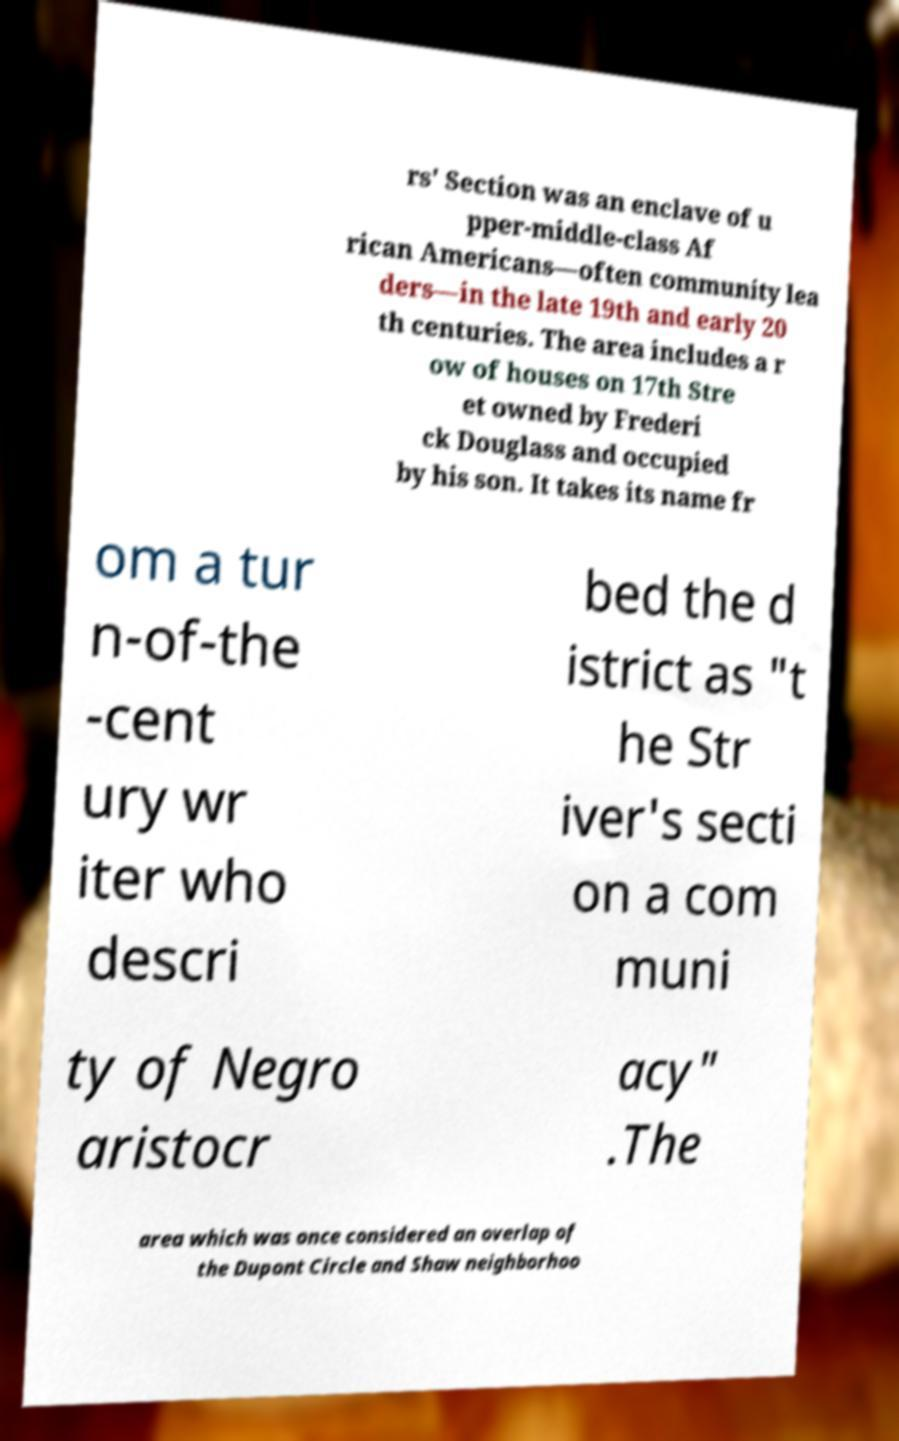There's text embedded in this image that I need extracted. Can you transcribe it verbatim? rs' Section was an enclave of u pper-middle-class Af rican Americans—often community lea ders—in the late 19th and early 20 th centuries. The area includes a r ow of houses on 17th Stre et owned by Frederi ck Douglass and occupied by his son. It takes its name fr om a tur n-of-the -cent ury wr iter who descri bed the d istrict as "t he Str iver's secti on a com muni ty of Negro aristocr acy" .The area which was once considered an overlap of the Dupont Circle and Shaw neighborhoo 